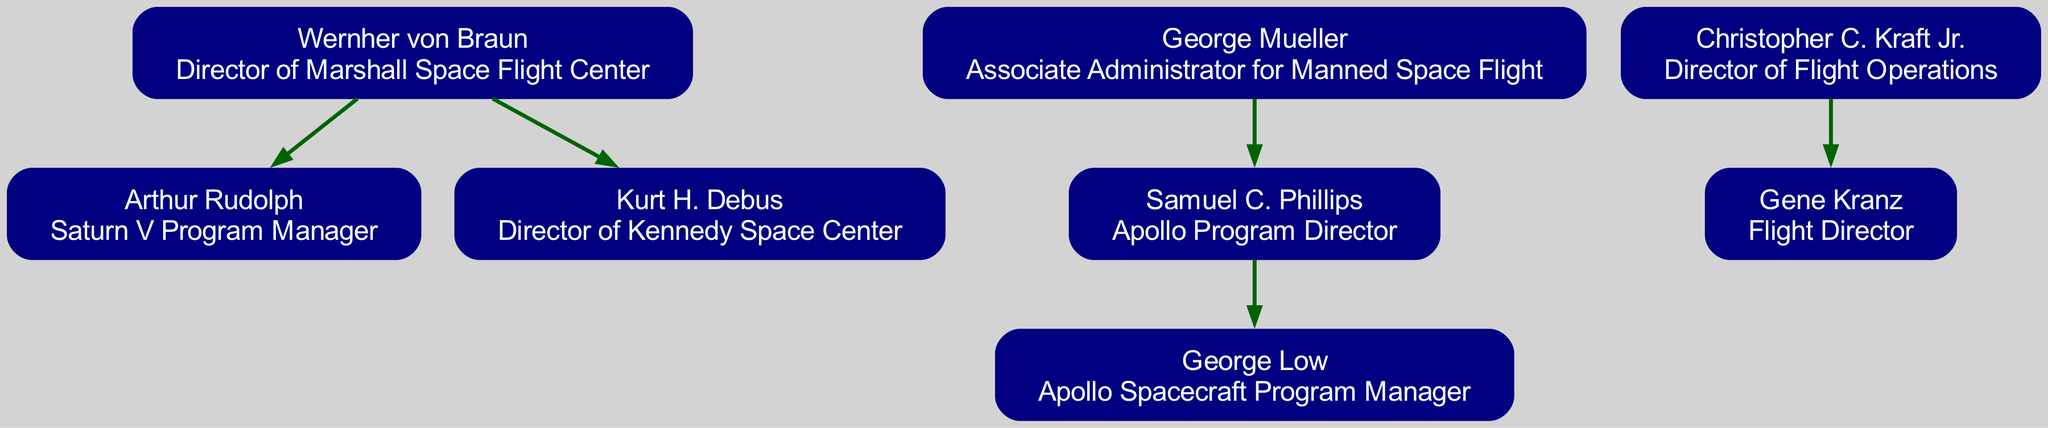What is the role of Wernher von Braun? Wernher von Braun is listed in the diagram as the "Director of Marshall Space Flight Center." This can be found directly under his name in the node corresponding to him.
Answer: Director of Marshall Space Flight Center Who are the children of George Mueller? The diagram specifies that George Mueller has one child, which is Samuel C. Phillips. This relationship can be traced from the node for George Mueller down to the node for Samuel C. Phillips.
Answer: Samuel C. Phillips How many children does Wernher von Braun have? According to the diagram, Wernher von Braun has two children: Arthur Rudolph and Kurt H. Debus. This information is found under his node where it lists his children.
Answer: 2 Which personnel is the Apollo Program Director? The diagram indicates that Samuel C. Phillips holds the title of Apollo Program Director. This title is shown directly beneath his name in his corresponding node.
Answer: Apollo Program Director Who is the Flight Director? The diagram shows that Gene Kranz is the Flight Director. This can be found at the node indicating Gene Kranz's role, which states "Flight Director" below his name.
Answer: Flight Director What is the relationship between George Low and Samuel C. Phillips? George Low is the child of Samuel C. Phillips, as depicted in the diagram. This relationship is represented by a directed edge connecting the node for Samuel C. Phillips to the node for George Low.
Answer: Child Which key personnel is associated with the Saturn V Program? The diagram states that Arthur Rudolph is associated with the Saturn V Program, indicated in the node where his role is described as "Saturn V Program Manager."
Answer: Arthur Rudolph How many key personnel in the Apollo program are listed in the diagram? By counting the unique nodes in the diagram, it can be determined that there are a total of six key personnel listed. Each individual is represented by their own node in the genealogy structure.
Answer: 6 What is the role of Kurt H. Debus? The diagram specifies that Kurt H. Debus is the "Director of Kennedy Space Center." This information is directly found in the node where his role is described beneath his name.
Answer: Director of Kennedy Space Center 